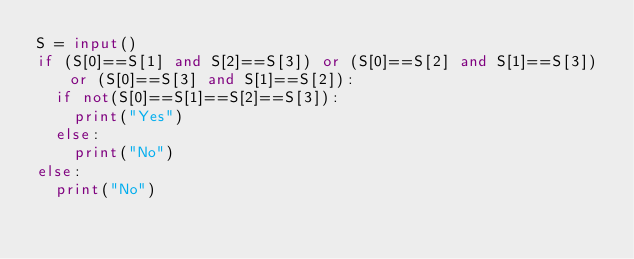<code> <loc_0><loc_0><loc_500><loc_500><_Python_>S = input()
if (S[0]==S[1] and S[2]==S[3]) or (S[0]==S[2] and S[1]==S[3]) or (S[0]==S[3] and S[1]==S[2]):
  if not(S[0]==S[1]==S[2]==S[3]):
    print("Yes")
  else:
    print("No")
else:
  print("No")</code> 